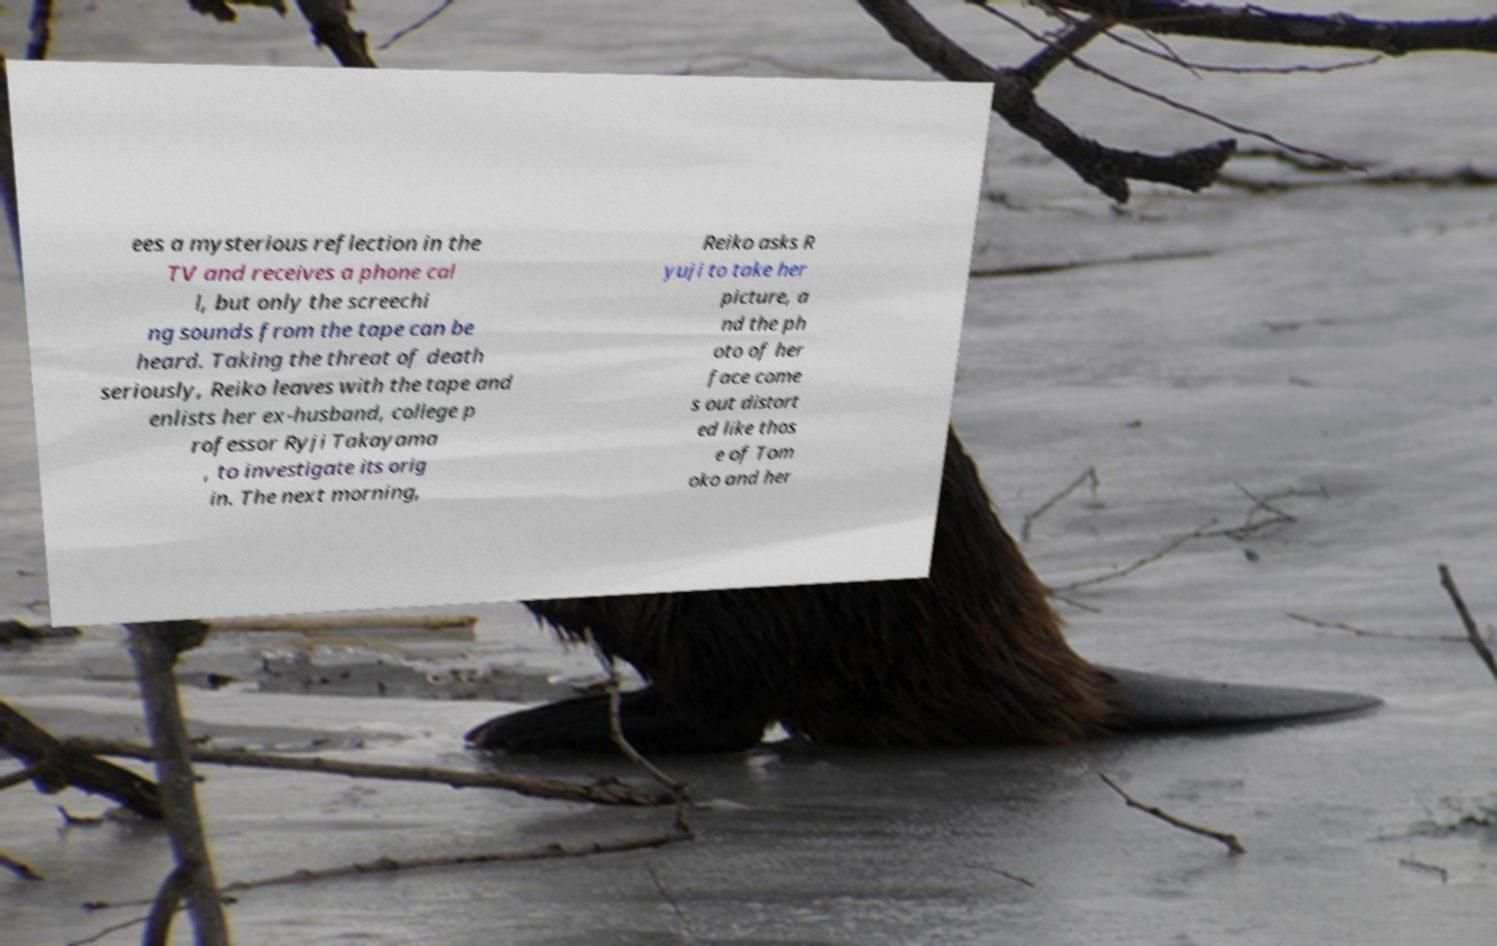There's text embedded in this image that I need extracted. Can you transcribe it verbatim? ees a mysterious reflection in the TV and receives a phone cal l, but only the screechi ng sounds from the tape can be heard. Taking the threat of death seriously, Reiko leaves with the tape and enlists her ex-husband, college p rofessor Ryji Takayama , to investigate its orig in. The next morning, Reiko asks R yuji to take her picture, a nd the ph oto of her face come s out distort ed like thos e of Tom oko and her 